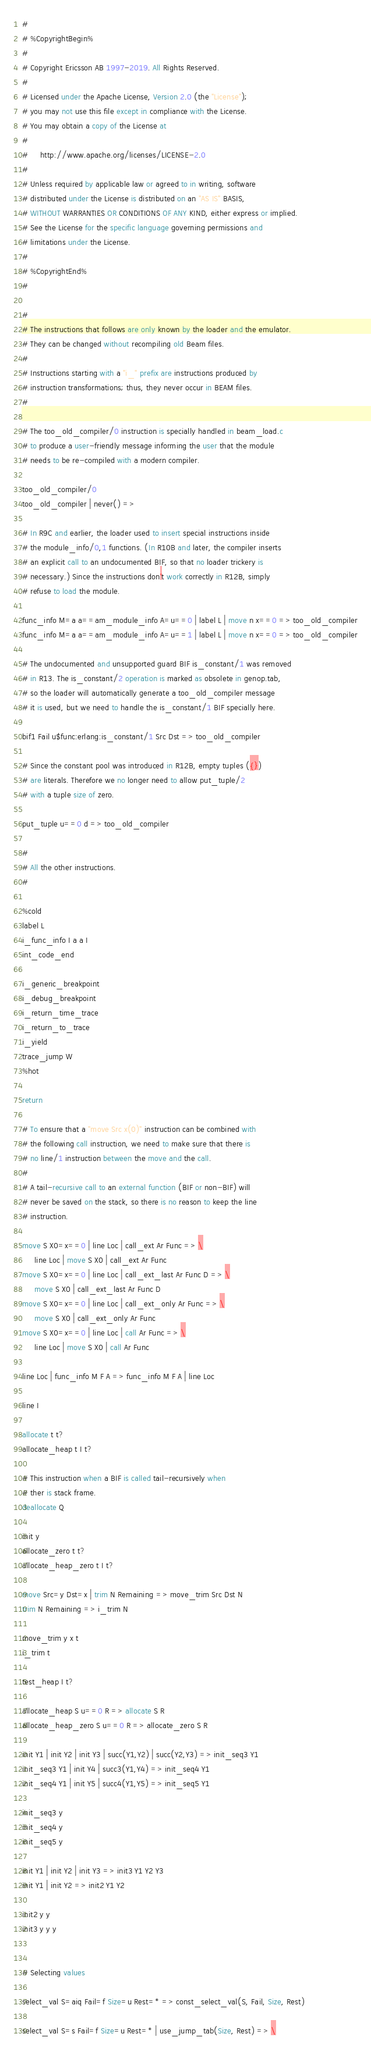Convert code to text. <code><loc_0><loc_0><loc_500><loc_500><_SQL_>#
# %CopyrightBegin%
#
# Copyright Ericsson AB 1997-2019. All Rights Reserved.
#
# Licensed under the Apache License, Version 2.0 (the "License");
# you may not use this file except in compliance with the License.
# You may obtain a copy of the License at
#
#     http://www.apache.org/licenses/LICENSE-2.0
#
# Unless required by applicable law or agreed to in writing, software
# distributed under the License is distributed on an "AS IS" BASIS,
# WITHOUT WARRANTIES OR CONDITIONS OF ANY KIND, either express or implied.
# See the License for the specific language governing permissions and
# limitations under the License.
#
# %CopyrightEnd%
#

#
# The instructions that follows are only known by the loader and the emulator.
# They can be changed without recompiling old Beam files.
#
# Instructions starting with a "i_" prefix are instructions produced by
# instruction transformations; thus, they never occur in BEAM files.
#

# The too_old_compiler/0 instruction is specially handled in beam_load.c
# to produce a user-friendly message informing the user that the module
# needs to be re-compiled with a modern compiler.

too_old_compiler/0
too_old_compiler | never() =>

# In R9C and earlier, the loader used to insert special instructions inside
# the module_info/0,1 functions. (In R10B and later, the compiler inserts
# an explicit call to an undocumented BIF, so that no loader trickery is
# necessary.) Since the instructions don't work correctly in R12B, simply
# refuse to load the module.

func_info M=a a==am_module_info A=u==0 | label L | move n x==0 => too_old_compiler
func_info M=a a==am_module_info A=u==1 | label L | move n x==0 => too_old_compiler

# The undocumented and unsupported guard BIF is_constant/1 was removed
# in R13. The is_constant/2 operation is marked as obsolete in genop.tab,
# so the loader will automatically generate a too_old_compiler message
# it is used, but we need to handle the is_constant/1 BIF specially here.

bif1 Fail u$func:erlang:is_constant/1 Src Dst => too_old_compiler

# Since the constant pool was introduced in R12B, empty tuples ({})
# are literals. Therefore we no longer need to allow put_tuple/2
# with a tuple size of zero.

put_tuple u==0 d => too_old_compiler

#
# All the other instructions.
#

%cold
label L
i_func_info I a a I
int_code_end

i_generic_breakpoint
i_debug_breakpoint
i_return_time_trace
i_return_to_trace
i_yield
trace_jump W
%hot

return

# To ensure that a "move Src x(0)" instruction can be combined with
# the following call instruction, we need to make sure that there is
# no line/1 instruction between the move and the call.
#
# A tail-recursive call to an external function (BIF or non-BIF) will
# never be saved on the stack, so there is no reason to keep the line
# instruction.

move S X0=x==0 | line Loc | call_ext Ar Func => \
     line Loc | move S X0 | call_ext Ar Func
move S X0=x==0 | line Loc | call_ext_last Ar Func D => \
     move S X0 | call_ext_last Ar Func D
move S X0=x==0 | line Loc | call_ext_only Ar Func => \
     move S X0 | call_ext_only Ar Func
move S X0=x==0 | line Loc | call Ar Func => \
     line Loc | move S X0 | call Ar Func

line Loc | func_info M F A => func_info M F A | line Loc

line I

allocate t t?
allocate_heap t I t?

# This instruction when a BIF is called tail-recursively when
# ther is stack frame.
deallocate Q

init y
allocate_zero t t?
allocate_heap_zero t I t?

move Src=y Dst=x | trim N Remaining => move_trim Src Dst N
trim N Remaining => i_trim N

move_trim y x t
i_trim t

test_heap I t?

allocate_heap S u==0 R => allocate S R
allocate_heap_zero S u==0 R => allocate_zero S R

init Y1 | init Y2 | init Y3 | succ(Y1,Y2) | succ(Y2,Y3) => init_seq3 Y1
init_seq3 Y1 | init Y4 | succ3(Y1,Y4) => init_seq4 Y1
init_seq4 Y1 | init Y5 | succ4(Y1,Y5) => init_seq5 Y1

init_seq3 y
init_seq4 y
init_seq5 y

init Y1 | init Y2 | init Y3 => init3 Y1 Y2 Y3
init Y1 | init Y2 => init2 Y1 Y2

init2 y y
init3 y y y


# Selecting values

select_val S=aiq Fail=f Size=u Rest=* => const_select_val(S, Fail, Size, Rest)

select_val S=s Fail=f Size=u Rest=* | use_jump_tab(Size, Rest) => \</code> 